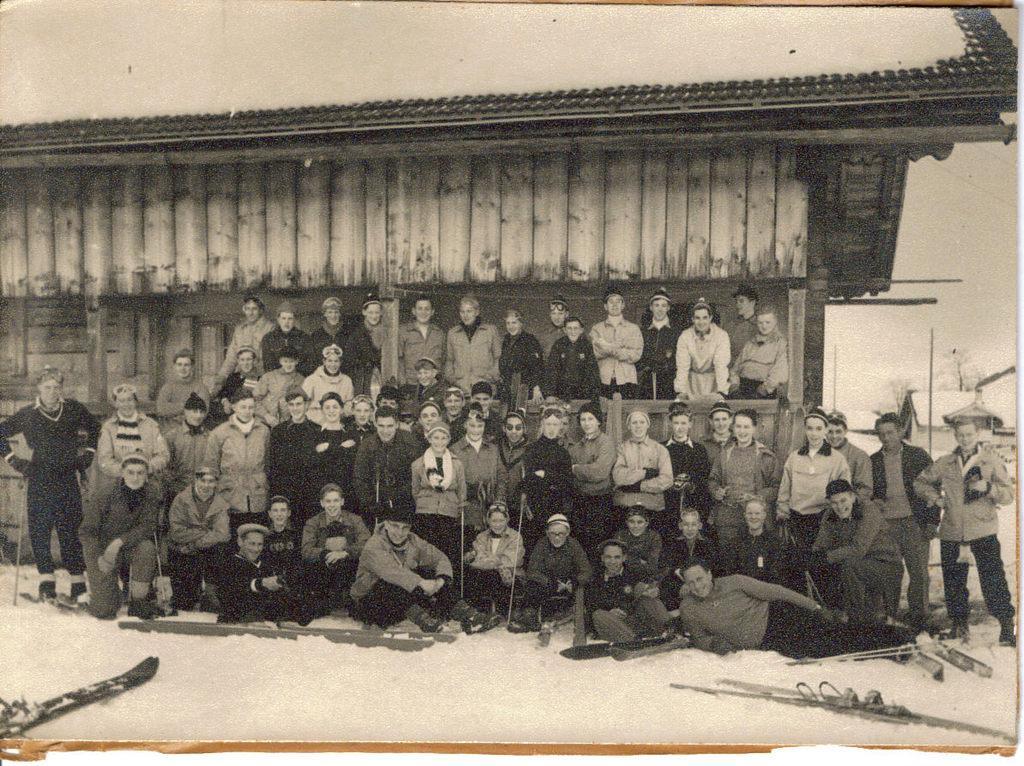In one or two sentences, can you explain what this image depicts? In this image we can see there are a few people standing and few people sitting and holding sticks. And there is the other person lying on the snow. We can see there are ski boards. At the back we can see there are buildings and poles. 